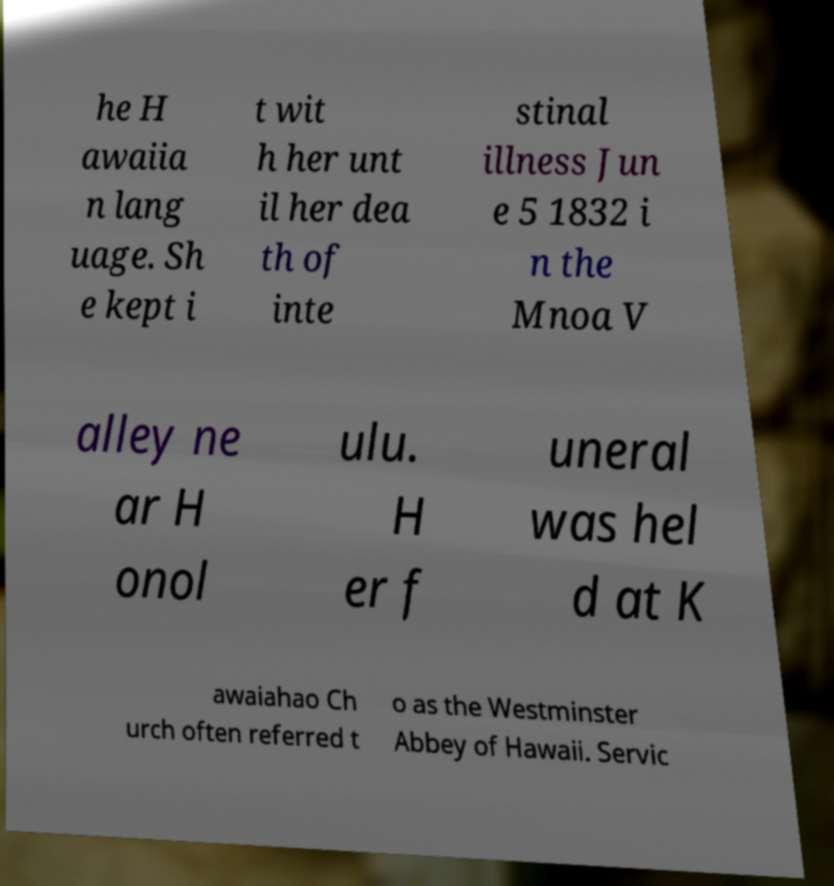Could you assist in decoding the text presented in this image and type it out clearly? he H awaiia n lang uage. Sh e kept i t wit h her unt il her dea th of inte stinal illness Jun e 5 1832 i n the Mnoa V alley ne ar H onol ulu. H er f uneral was hel d at K awaiahao Ch urch often referred t o as the Westminster Abbey of Hawaii. Servic 